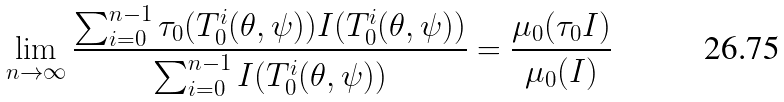Convert formula to latex. <formula><loc_0><loc_0><loc_500><loc_500>\lim _ { n \to \infty } \frac { \sum _ { i = 0 } ^ { n - 1 } \tau _ { 0 } ( T _ { 0 } ^ { i } ( \theta , \psi ) ) I ( T _ { 0 } ^ { i } ( \theta , \psi ) ) } { \sum _ { i = 0 } ^ { n - 1 } I ( T _ { 0 } ^ { i } ( \theta , \psi ) ) } = \frac { \mu _ { 0 } ( \tau _ { 0 } I ) } { \mu _ { 0 } ( I ) }</formula> 